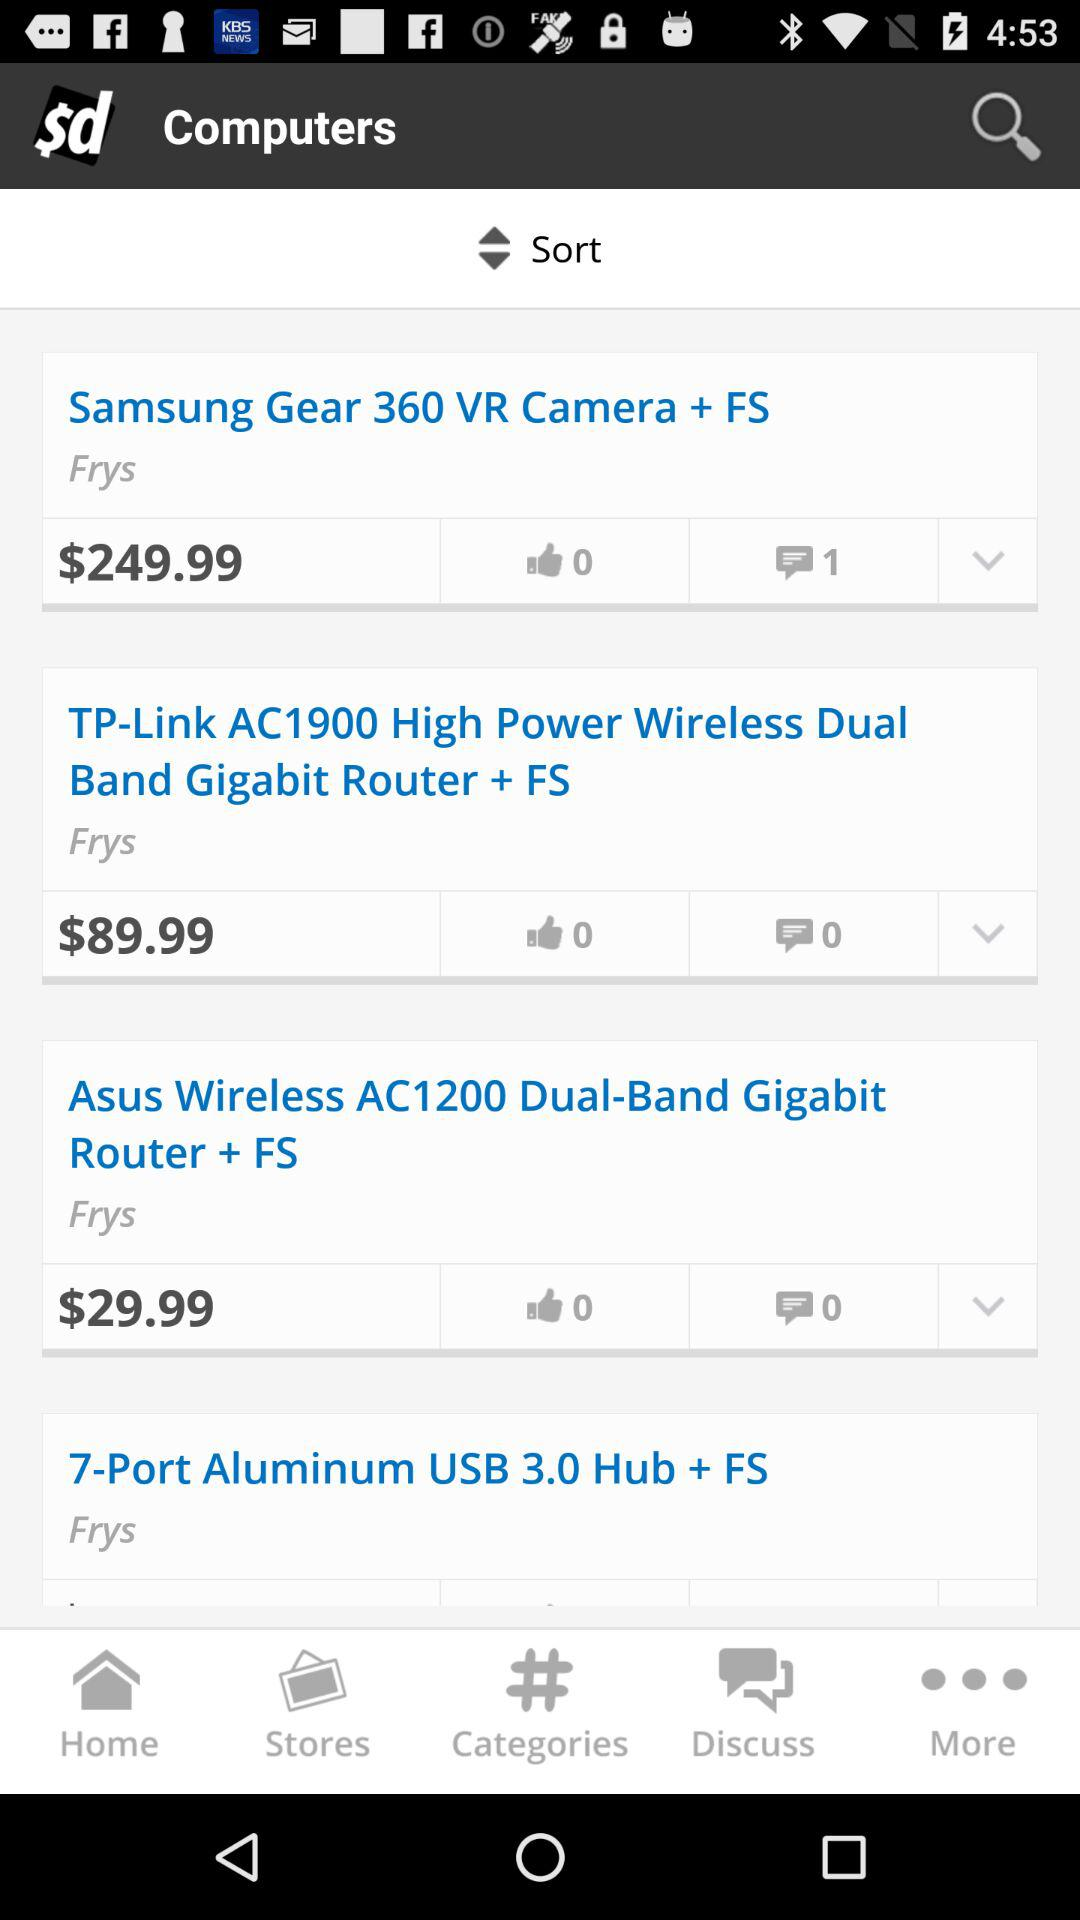Which item has a price of $29.99? The item is "Asus Wireless AC1200 Dual-Band Gigabit Router + FS". 